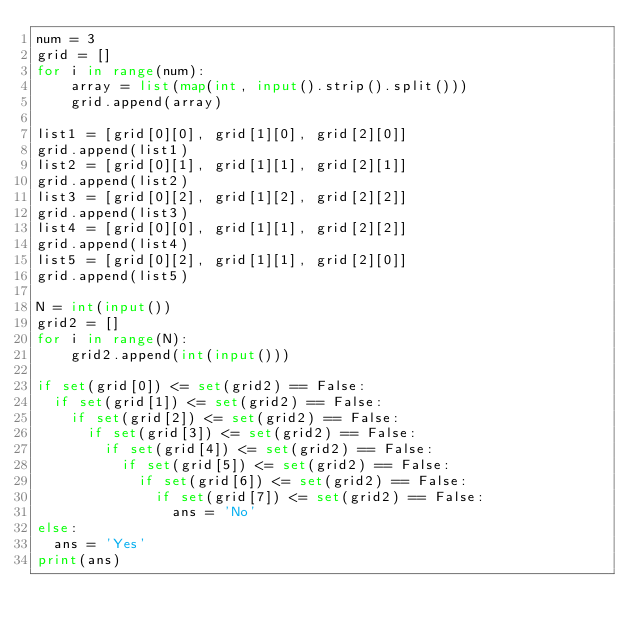Convert code to text. <code><loc_0><loc_0><loc_500><loc_500><_Python_>num = 3
grid = []
for i in range(num):
    array = list(map(int, input().strip().split()))
    grid.append(array)

list1 = [grid[0][0], grid[1][0], grid[2][0]]
grid.append(list1)
list2 = [grid[0][1], grid[1][1], grid[2][1]]
grid.append(list2)
list3 = [grid[0][2], grid[1][2], grid[2][2]]
grid.append(list3)
list4 = [grid[0][0], grid[1][1], grid[2][2]]
grid.append(list4)
list5 = [grid[0][2], grid[1][1], grid[2][0]]
grid.append(list5)

N = int(input())
grid2 = []
for i in range(N):
    grid2.append(int(input()))

if set(grid[0]) <= set(grid2) == False:
  if set(grid[1]) <= set(grid2) == False:
    if set(grid[2]) <= set(grid2) == False:
      if set(grid[3]) <= set(grid2) == False:
        if set(grid[4]) <= set(grid2) == False:
          if set(grid[5]) <= set(grid2) == False:
            if set(grid[6]) <= set(grid2) == False:
              if set(grid[7]) <= set(grid2) == False:
                ans = 'No'
else:
  ans = 'Yes'
print(ans)</code> 